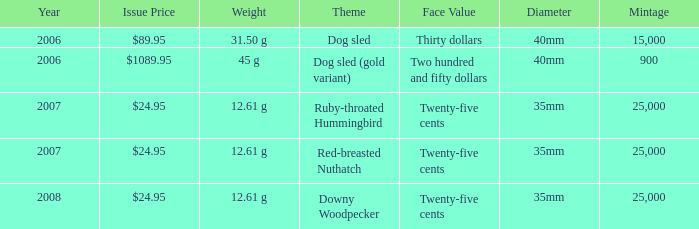What is the Mintage of the 12.61 g Weight Ruby-Throated Hummingbird? 1.0. Would you mind parsing the complete table? {'header': ['Year', 'Issue Price', 'Weight', 'Theme', 'Face Value', 'Diameter', 'Mintage'], 'rows': [['2006', '$89.95', '31.50 g', 'Dog sled', 'Thirty dollars', '40mm', '15,000'], ['2006', '$1089.95', '45 g', 'Dog sled (gold variant)', 'Two hundred and fifty dollars', '40mm', '900'], ['2007', '$24.95', '12.61 g', 'Ruby-throated Hummingbird', 'Twenty-five cents', '35mm', '25,000'], ['2007', '$24.95', '12.61 g', 'Red-breasted Nuthatch', 'Twenty-five cents', '35mm', '25,000'], ['2008', '$24.95', '12.61 g', 'Downy Woodpecker', 'Twenty-five cents', '35mm', '25,000']]} 